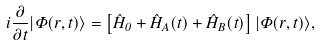<formula> <loc_0><loc_0><loc_500><loc_500>i \frac { \partial } { \partial t } | \Phi ( \vec { r } , t ) \rangle = \left [ \hat { H } _ { 0 } + \hat { H } _ { A } ( t ) + \hat { H } _ { B } ( t ) \right ] | \Phi ( \vec { r } , t ) \rangle ,</formula> 